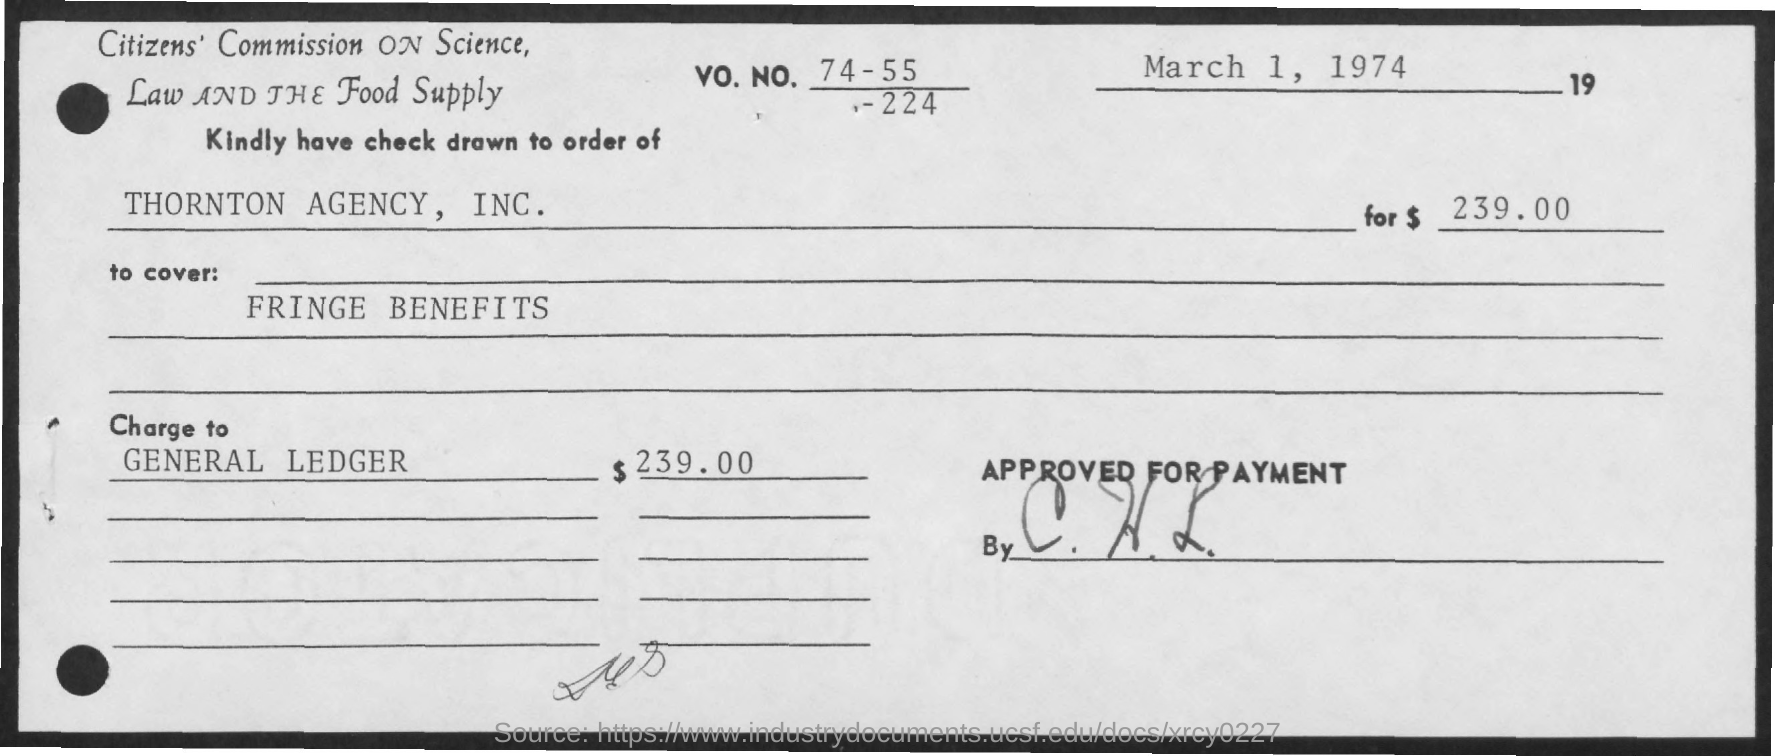When was the check issued?
Make the answer very short. March 1, 1974. Whom do the check issued?
Provide a succinct answer. THORNTON AGENCY, INC. How many dollars were written on check?
Provide a short and direct response. 239.00. 